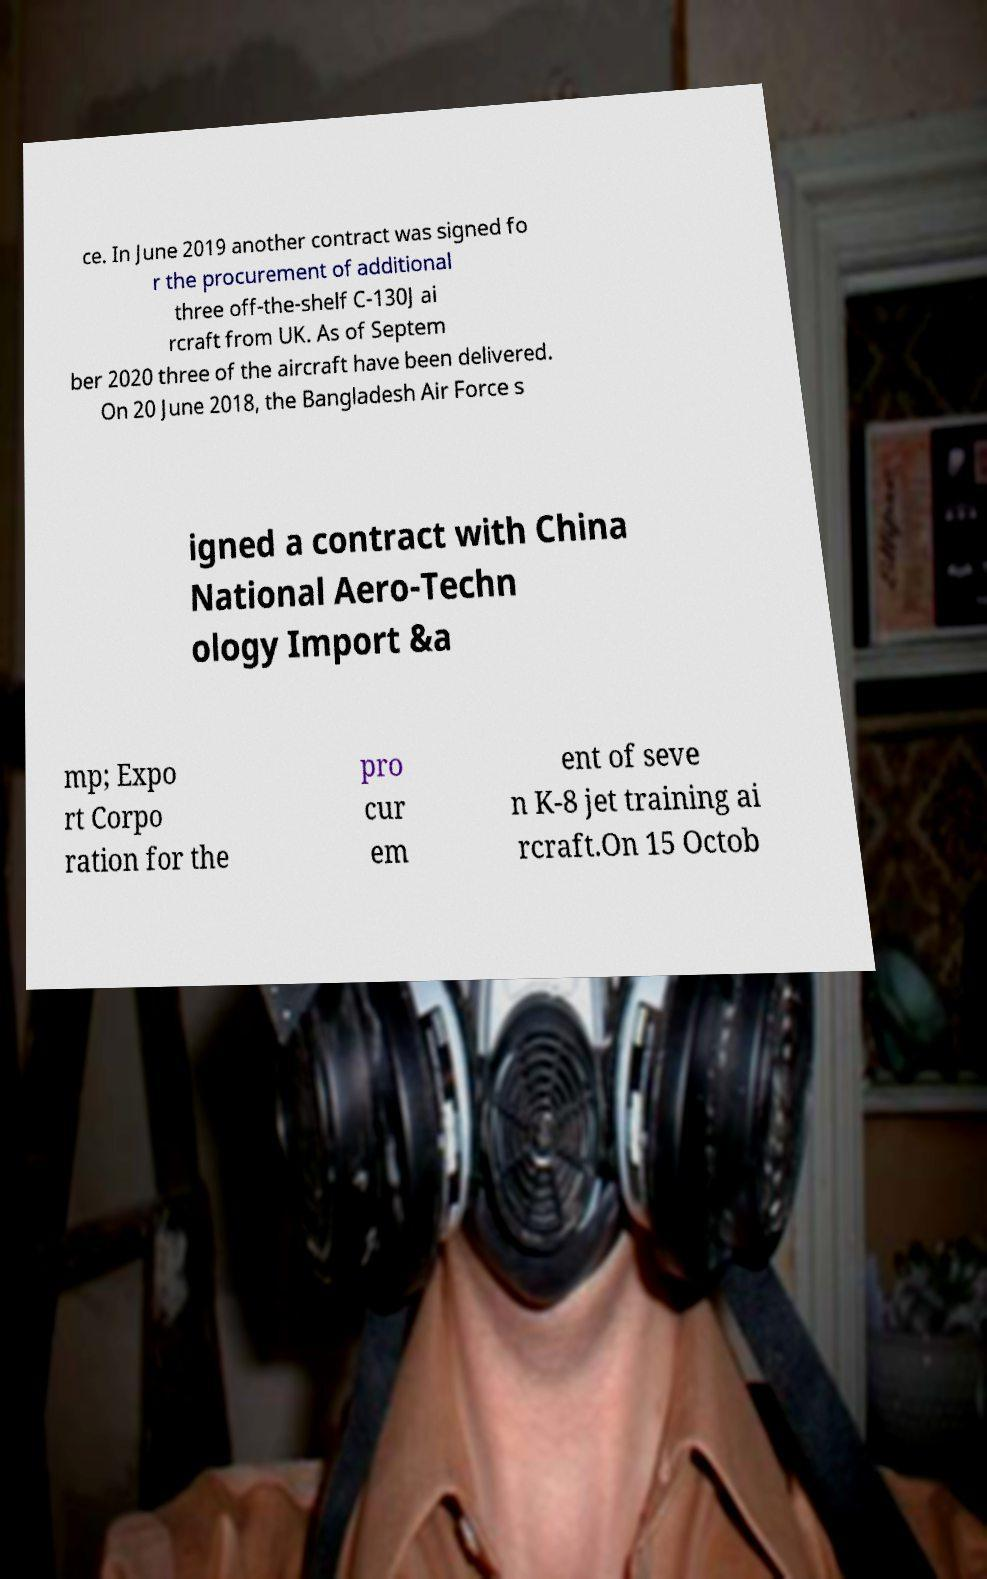Please identify and transcribe the text found in this image. ce. In June 2019 another contract was signed fo r the procurement of additional three off-the-shelf C-130J ai rcraft from UK. As of Septem ber 2020 three of the aircraft have been delivered. On 20 June 2018, the Bangladesh Air Force s igned a contract with China National Aero-Techn ology Import &a mp; Expo rt Corpo ration for the pro cur em ent of seve n K-8 jet training ai rcraft.On 15 Octob 